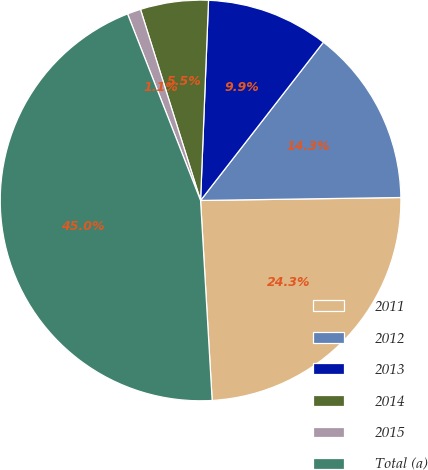Convert chart. <chart><loc_0><loc_0><loc_500><loc_500><pie_chart><fcel>2011<fcel>2012<fcel>2013<fcel>2014<fcel>2015<fcel>Total (a)<nl><fcel>24.31%<fcel>14.26%<fcel>9.87%<fcel>5.48%<fcel>1.09%<fcel>44.98%<nl></chart> 